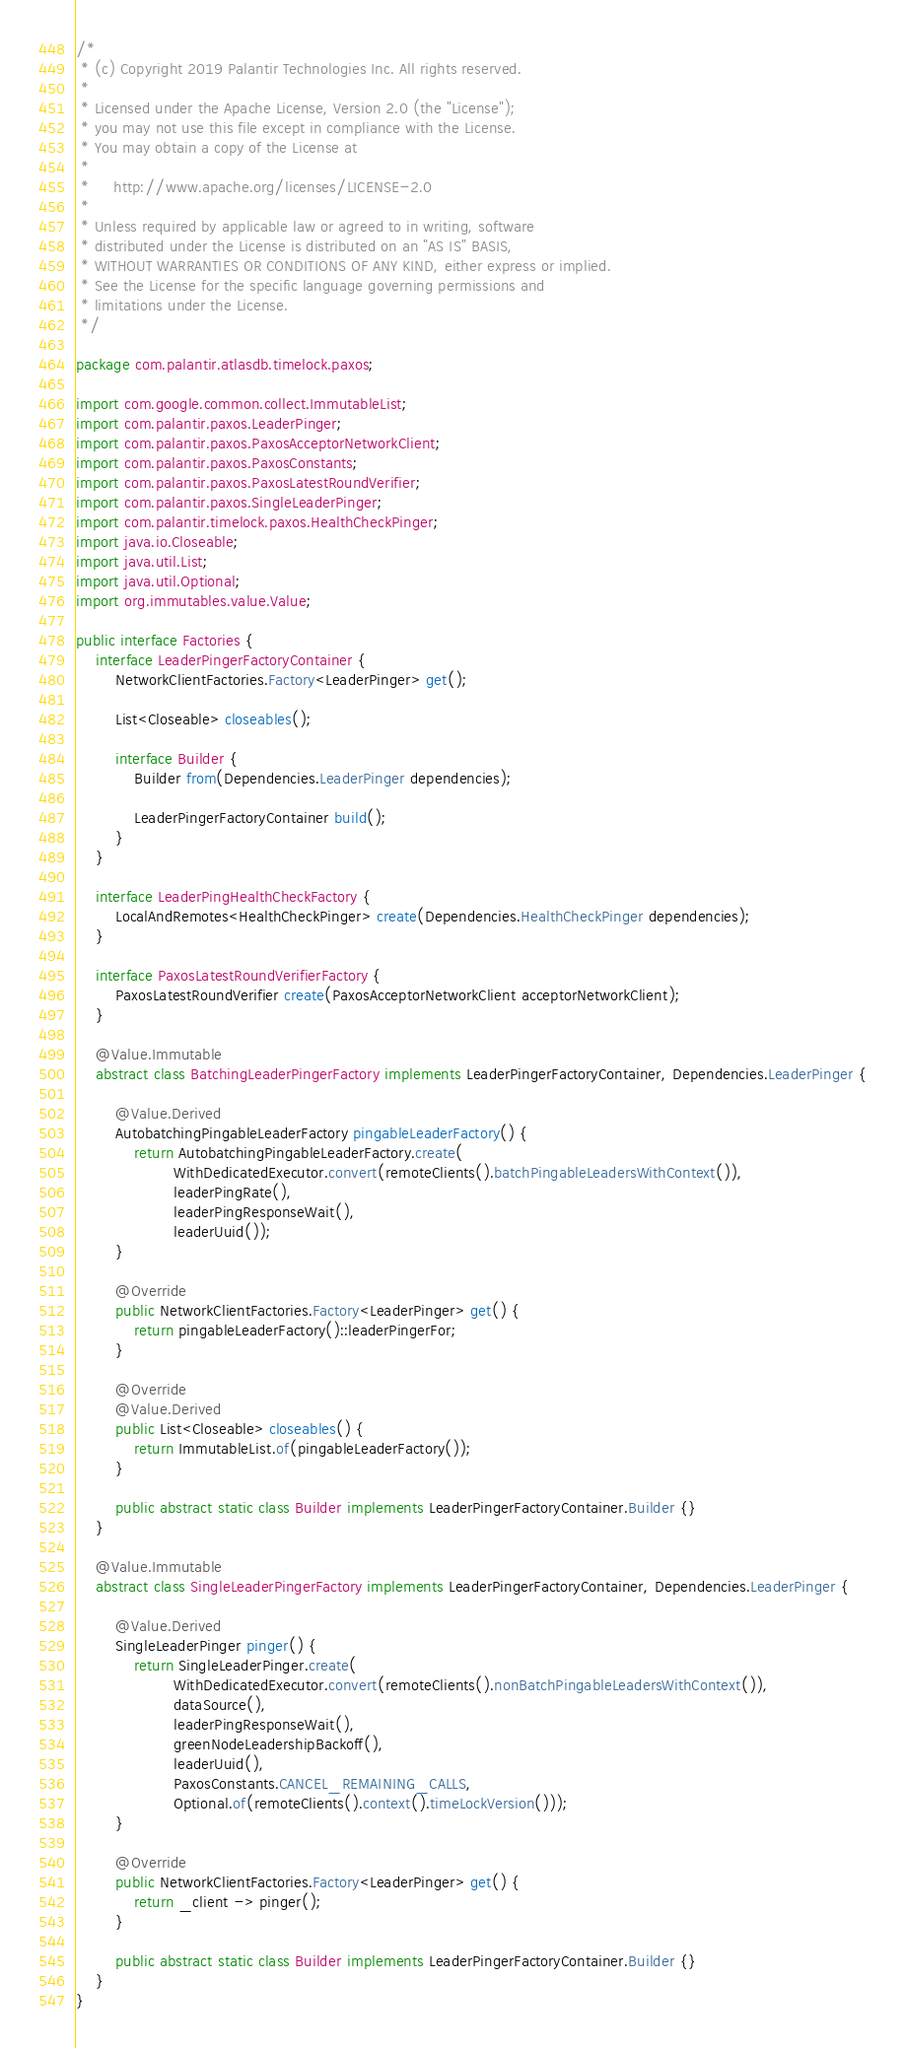<code> <loc_0><loc_0><loc_500><loc_500><_Java_>/*
 * (c) Copyright 2019 Palantir Technologies Inc. All rights reserved.
 *
 * Licensed under the Apache License, Version 2.0 (the "License");
 * you may not use this file except in compliance with the License.
 * You may obtain a copy of the License at
 *
 *     http://www.apache.org/licenses/LICENSE-2.0
 *
 * Unless required by applicable law or agreed to in writing, software
 * distributed under the License is distributed on an "AS IS" BASIS,
 * WITHOUT WARRANTIES OR CONDITIONS OF ANY KIND, either express or implied.
 * See the License for the specific language governing permissions and
 * limitations under the License.
 */

package com.palantir.atlasdb.timelock.paxos;

import com.google.common.collect.ImmutableList;
import com.palantir.paxos.LeaderPinger;
import com.palantir.paxos.PaxosAcceptorNetworkClient;
import com.palantir.paxos.PaxosConstants;
import com.palantir.paxos.PaxosLatestRoundVerifier;
import com.palantir.paxos.SingleLeaderPinger;
import com.palantir.timelock.paxos.HealthCheckPinger;
import java.io.Closeable;
import java.util.List;
import java.util.Optional;
import org.immutables.value.Value;

public interface Factories {
    interface LeaderPingerFactoryContainer {
        NetworkClientFactories.Factory<LeaderPinger> get();

        List<Closeable> closeables();

        interface Builder {
            Builder from(Dependencies.LeaderPinger dependencies);

            LeaderPingerFactoryContainer build();
        }
    }

    interface LeaderPingHealthCheckFactory {
        LocalAndRemotes<HealthCheckPinger> create(Dependencies.HealthCheckPinger dependencies);
    }

    interface PaxosLatestRoundVerifierFactory {
        PaxosLatestRoundVerifier create(PaxosAcceptorNetworkClient acceptorNetworkClient);
    }

    @Value.Immutable
    abstract class BatchingLeaderPingerFactory implements LeaderPingerFactoryContainer, Dependencies.LeaderPinger {

        @Value.Derived
        AutobatchingPingableLeaderFactory pingableLeaderFactory() {
            return AutobatchingPingableLeaderFactory.create(
                    WithDedicatedExecutor.convert(remoteClients().batchPingableLeadersWithContext()),
                    leaderPingRate(),
                    leaderPingResponseWait(),
                    leaderUuid());
        }

        @Override
        public NetworkClientFactories.Factory<LeaderPinger> get() {
            return pingableLeaderFactory()::leaderPingerFor;
        }

        @Override
        @Value.Derived
        public List<Closeable> closeables() {
            return ImmutableList.of(pingableLeaderFactory());
        }

        public abstract static class Builder implements LeaderPingerFactoryContainer.Builder {}
    }

    @Value.Immutable
    abstract class SingleLeaderPingerFactory implements LeaderPingerFactoryContainer, Dependencies.LeaderPinger {

        @Value.Derived
        SingleLeaderPinger pinger() {
            return SingleLeaderPinger.create(
                    WithDedicatedExecutor.convert(remoteClients().nonBatchPingableLeadersWithContext()),
                    dataSource(),
                    leaderPingResponseWait(),
                    greenNodeLeadershipBackoff(),
                    leaderUuid(),
                    PaxosConstants.CANCEL_REMAINING_CALLS,
                    Optional.of(remoteClients().context().timeLockVersion()));
        }

        @Override
        public NetworkClientFactories.Factory<LeaderPinger> get() {
            return _client -> pinger();
        }

        public abstract static class Builder implements LeaderPingerFactoryContainer.Builder {}
    }
}
</code> 